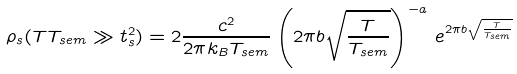<formula> <loc_0><loc_0><loc_500><loc_500>\rho _ { s } ( T T _ { s e m } \gg t _ { s } ^ { 2 } ) = 2 \frac { c ^ { 2 } } { 2 \pi k _ { B } T _ { s e m } } \left ( 2 \pi b \sqrt { \frac { T } { T _ { s e m } } } \right ) ^ { - a } \, e ^ { 2 \pi b \sqrt { \frac { T } { T _ { s e m } } } }</formula> 